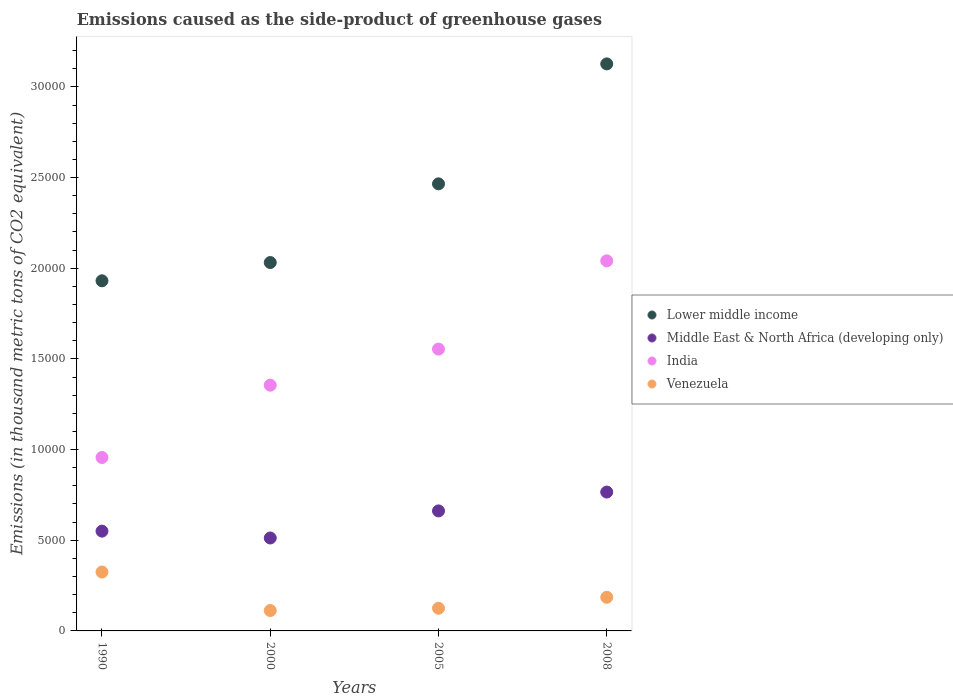How many different coloured dotlines are there?
Make the answer very short. 4. What is the emissions caused as the side-product of greenhouse gases in Middle East & North Africa (developing only) in 2000?
Provide a succinct answer. 5124.9. Across all years, what is the maximum emissions caused as the side-product of greenhouse gases in Middle East & North Africa (developing only)?
Ensure brevity in your answer.  7657.2. Across all years, what is the minimum emissions caused as the side-product of greenhouse gases in Lower middle income?
Provide a short and direct response. 1.93e+04. In which year was the emissions caused as the side-product of greenhouse gases in Lower middle income maximum?
Keep it short and to the point. 2008. What is the total emissions caused as the side-product of greenhouse gases in Middle East & North Africa (developing only) in the graph?
Your answer should be compact. 2.49e+04. What is the difference between the emissions caused as the side-product of greenhouse gases in India in 2000 and that in 2005?
Offer a terse response. -1989. What is the difference between the emissions caused as the side-product of greenhouse gases in Venezuela in 1990 and the emissions caused as the side-product of greenhouse gases in Lower middle income in 2008?
Keep it short and to the point. -2.80e+04. What is the average emissions caused as the side-product of greenhouse gases in Middle East & North Africa (developing only) per year?
Offer a terse response. 6225.62. In the year 2000, what is the difference between the emissions caused as the side-product of greenhouse gases in Venezuela and emissions caused as the side-product of greenhouse gases in India?
Offer a terse response. -1.24e+04. In how many years, is the emissions caused as the side-product of greenhouse gases in Venezuela greater than 30000 thousand metric tons?
Your answer should be very brief. 0. What is the ratio of the emissions caused as the side-product of greenhouse gases in Venezuela in 1990 to that in 2005?
Offer a terse response. 2.6. What is the difference between the highest and the second highest emissions caused as the side-product of greenhouse gases in Middle East & North Africa (developing only)?
Your answer should be very brief. 1039.4. What is the difference between the highest and the lowest emissions caused as the side-product of greenhouse gases in Middle East & North Africa (developing only)?
Your answer should be compact. 2532.3. In how many years, is the emissions caused as the side-product of greenhouse gases in Middle East & North Africa (developing only) greater than the average emissions caused as the side-product of greenhouse gases in Middle East & North Africa (developing only) taken over all years?
Offer a very short reply. 2. Is the sum of the emissions caused as the side-product of greenhouse gases in Middle East & North Africa (developing only) in 2005 and 2008 greater than the maximum emissions caused as the side-product of greenhouse gases in India across all years?
Provide a short and direct response. No. Is it the case that in every year, the sum of the emissions caused as the side-product of greenhouse gases in Lower middle income and emissions caused as the side-product of greenhouse gases in India  is greater than the emissions caused as the side-product of greenhouse gases in Venezuela?
Keep it short and to the point. Yes. Does the emissions caused as the side-product of greenhouse gases in Venezuela monotonically increase over the years?
Provide a succinct answer. No. Is the emissions caused as the side-product of greenhouse gases in Middle East & North Africa (developing only) strictly greater than the emissions caused as the side-product of greenhouse gases in Venezuela over the years?
Offer a very short reply. Yes. Is the emissions caused as the side-product of greenhouse gases in Lower middle income strictly less than the emissions caused as the side-product of greenhouse gases in India over the years?
Keep it short and to the point. No. How many years are there in the graph?
Provide a short and direct response. 4. Are the values on the major ticks of Y-axis written in scientific E-notation?
Provide a succinct answer. No. Where does the legend appear in the graph?
Your response must be concise. Center right. How many legend labels are there?
Keep it short and to the point. 4. What is the title of the graph?
Your response must be concise. Emissions caused as the side-product of greenhouse gases. What is the label or title of the Y-axis?
Your answer should be very brief. Emissions (in thousand metric tons of CO2 equivalent). What is the Emissions (in thousand metric tons of CO2 equivalent) in Lower middle income in 1990?
Your response must be concise. 1.93e+04. What is the Emissions (in thousand metric tons of CO2 equivalent) in Middle East & North Africa (developing only) in 1990?
Give a very brief answer. 5502.6. What is the Emissions (in thousand metric tons of CO2 equivalent) of India in 1990?
Your answer should be compact. 9563.6. What is the Emissions (in thousand metric tons of CO2 equivalent) of Venezuela in 1990?
Offer a terse response. 3248.1. What is the Emissions (in thousand metric tons of CO2 equivalent) of Lower middle income in 2000?
Ensure brevity in your answer.  2.03e+04. What is the Emissions (in thousand metric tons of CO2 equivalent) in Middle East & North Africa (developing only) in 2000?
Your response must be concise. 5124.9. What is the Emissions (in thousand metric tons of CO2 equivalent) of India in 2000?
Make the answer very short. 1.36e+04. What is the Emissions (in thousand metric tons of CO2 equivalent) in Venezuela in 2000?
Provide a succinct answer. 1124.5. What is the Emissions (in thousand metric tons of CO2 equivalent) in Lower middle income in 2005?
Make the answer very short. 2.47e+04. What is the Emissions (in thousand metric tons of CO2 equivalent) in Middle East & North Africa (developing only) in 2005?
Your answer should be very brief. 6617.8. What is the Emissions (in thousand metric tons of CO2 equivalent) of India in 2005?
Provide a succinct answer. 1.55e+04. What is the Emissions (in thousand metric tons of CO2 equivalent) in Venezuela in 2005?
Make the answer very short. 1249.6. What is the Emissions (in thousand metric tons of CO2 equivalent) of Lower middle income in 2008?
Ensure brevity in your answer.  3.13e+04. What is the Emissions (in thousand metric tons of CO2 equivalent) in Middle East & North Africa (developing only) in 2008?
Offer a very short reply. 7657.2. What is the Emissions (in thousand metric tons of CO2 equivalent) in India in 2008?
Your response must be concise. 2.04e+04. What is the Emissions (in thousand metric tons of CO2 equivalent) in Venezuela in 2008?
Offer a terse response. 1854.3. Across all years, what is the maximum Emissions (in thousand metric tons of CO2 equivalent) in Lower middle income?
Your response must be concise. 3.13e+04. Across all years, what is the maximum Emissions (in thousand metric tons of CO2 equivalent) of Middle East & North Africa (developing only)?
Provide a short and direct response. 7657.2. Across all years, what is the maximum Emissions (in thousand metric tons of CO2 equivalent) in India?
Make the answer very short. 2.04e+04. Across all years, what is the maximum Emissions (in thousand metric tons of CO2 equivalent) in Venezuela?
Keep it short and to the point. 3248.1. Across all years, what is the minimum Emissions (in thousand metric tons of CO2 equivalent) in Lower middle income?
Offer a very short reply. 1.93e+04. Across all years, what is the minimum Emissions (in thousand metric tons of CO2 equivalent) in Middle East & North Africa (developing only)?
Make the answer very short. 5124.9. Across all years, what is the minimum Emissions (in thousand metric tons of CO2 equivalent) in India?
Provide a short and direct response. 9563.6. Across all years, what is the minimum Emissions (in thousand metric tons of CO2 equivalent) in Venezuela?
Provide a succinct answer. 1124.5. What is the total Emissions (in thousand metric tons of CO2 equivalent) in Lower middle income in the graph?
Keep it short and to the point. 9.55e+04. What is the total Emissions (in thousand metric tons of CO2 equivalent) in Middle East & North Africa (developing only) in the graph?
Provide a succinct answer. 2.49e+04. What is the total Emissions (in thousand metric tons of CO2 equivalent) in India in the graph?
Provide a short and direct response. 5.91e+04. What is the total Emissions (in thousand metric tons of CO2 equivalent) in Venezuela in the graph?
Provide a short and direct response. 7476.5. What is the difference between the Emissions (in thousand metric tons of CO2 equivalent) in Lower middle income in 1990 and that in 2000?
Provide a short and direct response. -1007.9. What is the difference between the Emissions (in thousand metric tons of CO2 equivalent) of Middle East & North Africa (developing only) in 1990 and that in 2000?
Provide a succinct answer. 377.7. What is the difference between the Emissions (in thousand metric tons of CO2 equivalent) of India in 1990 and that in 2000?
Keep it short and to the point. -3987.1. What is the difference between the Emissions (in thousand metric tons of CO2 equivalent) in Venezuela in 1990 and that in 2000?
Your answer should be compact. 2123.6. What is the difference between the Emissions (in thousand metric tons of CO2 equivalent) in Lower middle income in 1990 and that in 2005?
Your response must be concise. -5347. What is the difference between the Emissions (in thousand metric tons of CO2 equivalent) of Middle East & North Africa (developing only) in 1990 and that in 2005?
Offer a very short reply. -1115.2. What is the difference between the Emissions (in thousand metric tons of CO2 equivalent) in India in 1990 and that in 2005?
Make the answer very short. -5976.1. What is the difference between the Emissions (in thousand metric tons of CO2 equivalent) of Venezuela in 1990 and that in 2005?
Your response must be concise. 1998.5. What is the difference between the Emissions (in thousand metric tons of CO2 equivalent) of Lower middle income in 1990 and that in 2008?
Provide a short and direct response. -1.20e+04. What is the difference between the Emissions (in thousand metric tons of CO2 equivalent) in Middle East & North Africa (developing only) in 1990 and that in 2008?
Your answer should be compact. -2154.6. What is the difference between the Emissions (in thousand metric tons of CO2 equivalent) of India in 1990 and that in 2008?
Ensure brevity in your answer.  -1.08e+04. What is the difference between the Emissions (in thousand metric tons of CO2 equivalent) in Venezuela in 1990 and that in 2008?
Your response must be concise. 1393.8. What is the difference between the Emissions (in thousand metric tons of CO2 equivalent) in Lower middle income in 2000 and that in 2005?
Provide a succinct answer. -4339.1. What is the difference between the Emissions (in thousand metric tons of CO2 equivalent) in Middle East & North Africa (developing only) in 2000 and that in 2005?
Provide a succinct answer. -1492.9. What is the difference between the Emissions (in thousand metric tons of CO2 equivalent) of India in 2000 and that in 2005?
Keep it short and to the point. -1989. What is the difference between the Emissions (in thousand metric tons of CO2 equivalent) in Venezuela in 2000 and that in 2005?
Keep it short and to the point. -125.1. What is the difference between the Emissions (in thousand metric tons of CO2 equivalent) of Lower middle income in 2000 and that in 2008?
Provide a short and direct response. -1.10e+04. What is the difference between the Emissions (in thousand metric tons of CO2 equivalent) in Middle East & North Africa (developing only) in 2000 and that in 2008?
Make the answer very short. -2532.3. What is the difference between the Emissions (in thousand metric tons of CO2 equivalent) of India in 2000 and that in 2008?
Keep it short and to the point. -6856.2. What is the difference between the Emissions (in thousand metric tons of CO2 equivalent) in Venezuela in 2000 and that in 2008?
Provide a short and direct response. -729.8. What is the difference between the Emissions (in thousand metric tons of CO2 equivalent) of Lower middle income in 2005 and that in 2008?
Your answer should be very brief. -6613.6. What is the difference between the Emissions (in thousand metric tons of CO2 equivalent) in Middle East & North Africa (developing only) in 2005 and that in 2008?
Provide a succinct answer. -1039.4. What is the difference between the Emissions (in thousand metric tons of CO2 equivalent) of India in 2005 and that in 2008?
Provide a succinct answer. -4867.2. What is the difference between the Emissions (in thousand metric tons of CO2 equivalent) of Venezuela in 2005 and that in 2008?
Your answer should be compact. -604.7. What is the difference between the Emissions (in thousand metric tons of CO2 equivalent) in Lower middle income in 1990 and the Emissions (in thousand metric tons of CO2 equivalent) in Middle East & North Africa (developing only) in 2000?
Your answer should be compact. 1.42e+04. What is the difference between the Emissions (in thousand metric tons of CO2 equivalent) in Lower middle income in 1990 and the Emissions (in thousand metric tons of CO2 equivalent) in India in 2000?
Your answer should be compact. 5755.7. What is the difference between the Emissions (in thousand metric tons of CO2 equivalent) in Lower middle income in 1990 and the Emissions (in thousand metric tons of CO2 equivalent) in Venezuela in 2000?
Keep it short and to the point. 1.82e+04. What is the difference between the Emissions (in thousand metric tons of CO2 equivalent) of Middle East & North Africa (developing only) in 1990 and the Emissions (in thousand metric tons of CO2 equivalent) of India in 2000?
Offer a terse response. -8048.1. What is the difference between the Emissions (in thousand metric tons of CO2 equivalent) of Middle East & North Africa (developing only) in 1990 and the Emissions (in thousand metric tons of CO2 equivalent) of Venezuela in 2000?
Provide a short and direct response. 4378.1. What is the difference between the Emissions (in thousand metric tons of CO2 equivalent) of India in 1990 and the Emissions (in thousand metric tons of CO2 equivalent) of Venezuela in 2000?
Your answer should be compact. 8439.1. What is the difference between the Emissions (in thousand metric tons of CO2 equivalent) of Lower middle income in 1990 and the Emissions (in thousand metric tons of CO2 equivalent) of Middle East & North Africa (developing only) in 2005?
Your answer should be compact. 1.27e+04. What is the difference between the Emissions (in thousand metric tons of CO2 equivalent) of Lower middle income in 1990 and the Emissions (in thousand metric tons of CO2 equivalent) of India in 2005?
Give a very brief answer. 3766.7. What is the difference between the Emissions (in thousand metric tons of CO2 equivalent) of Lower middle income in 1990 and the Emissions (in thousand metric tons of CO2 equivalent) of Venezuela in 2005?
Give a very brief answer. 1.81e+04. What is the difference between the Emissions (in thousand metric tons of CO2 equivalent) in Middle East & North Africa (developing only) in 1990 and the Emissions (in thousand metric tons of CO2 equivalent) in India in 2005?
Offer a very short reply. -1.00e+04. What is the difference between the Emissions (in thousand metric tons of CO2 equivalent) in Middle East & North Africa (developing only) in 1990 and the Emissions (in thousand metric tons of CO2 equivalent) in Venezuela in 2005?
Your answer should be very brief. 4253. What is the difference between the Emissions (in thousand metric tons of CO2 equivalent) in India in 1990 and the Emissions (in thousand metric tons of CO2 equivalent) in Venezuela in 2005?
Make the answer very short. 8314. What is the difference between the Emissions (in thousand metric tons of CO2 equivalent) of Lower middle income in 1990 and the Emissions (in thousand metric tons of CO2 equivalent) of Middle East & North Africa (developing only) in 2008?
Keep it short and to the point. 1.16e+04. What is the difference between the Emissions (in thousand metric tons of CO2 equivalent) of Lower middle income in 1990 and the Emissions (in thousand metric tons of CO2 equivalent) of India in 2008?
Offer a very short reply. -1100.5. What is the difference between the Emissions (in thousand metric tons of CO2 equivalent) of Lower middle income in 1990 and the Emissions (in thousand metric tons of CO2 equivalent) of Venezuela in 2008?
Provide a succinct answer. 1.75e+04. What is the difference between the Emissions (in thousand metric tons of CO2 equivalent) in Middle East & North Africa (developing only) in 1990 and the Emissions (in thousand metric tons of CO2 equivalent) in India in 2008?
Provide a succinct answer. -1.49e+04. What is the difference between the Emissions (in thousand metric tons of CO2 equivalent) in Middle East & North Africa (developing only) in 1990 and the Emissions (in thousand metric tons of CO2 equivalent) in Venezuela in 2008?
Make the answer very short. 3648.3. What is the difference between the Emissions (in thousand metric tons of CO2 equivalent) of India in 1990 and the Emissions (in thousand metric tons of CO2 equivalent) of Venezuela in 2008?
Give a very brief answer. 7709.3. What is the difference between the Emissions (in thousand metric tons of CO2 equivalent) of Lower middle income in 2000 and the Emissions (in thousand metric tons of CO2 equivalent) of Middle East & North Africa (developing only) in 2005?
Offer a terse response. 1.37e+04. What is the difference between the Emissions (in thousand metric tons of CO2 equivalent) of Lower middle income in 2000 and the Emissions (in thousand metric tons of CO2 equivalent) of India in 2005?
Your answer should be very brief. 4774.6. What is the difference between the Emissions (in thousand metric tons of CO2 equivalent) in Lower middle income in 2000 and the Emissions (in thousand metric tons of CO2 equivalent) in Venezuela in 2005?
Give a very brief answer. 1.91e+04. What is the difference between the Emissions (in thousand metric tons of CO2 equivalent) in Middle East & North Africa (developing only) in 2000 and the Emissions (in thousand metric tons of CO2 equivalent) in India in 2005?
Your answer should be compact. -1.04e+04. What is the difference between the Emissions (in thousand metric tons of CO2 equivalent) in Middle East & North Africa (developing only) in 2000 and the Emissions (in thousand metric tons of CO2 equivalent) in Venezuela in 2005?
Your answer should be compact. 3875.3. What is the difference between the Emissions (in thousand metric tons of CO2 equivalent) of India in 2000 and the Emissions (in thousand metric tons of CO2 equivalent) of Venezuela in 2005?
Provide a short and direct response. 1.23e+04. What is the difference between the Emissions (in thousand metric tons of CO2 equivalent) in Lower middle income in 2000 and the Emissions (in thousand metric tons of CO2 equivalent) in Middle East & North Africa (developing only) in 2008?
Keep it short and to the point. 1.27e+04. What is the difference between the Emissions (in thousand metric tons of CO2 equivalent) in Lower middle income in 2000 and the Emissions (in thousand metric tons of CO2 equivalent) in India in 2008?
Make the answer very short. -92.6. What is the difference between the Emissions (in thousand metric tons of CO2 equivalent) of Lower middle income in 2000 and the Emissions (in thousand metric tons of CO2 equivalent) of Venezuela in 2008?
Ensure brevity in your answer.  1.85e+04. What is the difference between the Emissions (in thousand metric tons of CO2 equivalent) in Middle East & North Africa (developing only) in 2000 and the Emissions (in thousand metric tons of CO2 equivalent) in India in 2008?
Make the answer very short. -1.53e+04. What is the difference between the Emissions (in thousand metric tons of CO2 equivalent) of Middle East & North Africa (developing only) in 2000 and the Emissions (in thousand metric tons of CO2 equivalent) of Venezuela in 2008?
Offer a very short reply. 3270.6. What is the difference between the Emissions (in thousand metric tons of CO2 equivalent) of India in 2000 and the Emissions (in thousand metric tons of CO2 equivalent) of Venezuela in 2008?
Your answer should be very brief. 1.17e+04. What is the difference between the Emissions (in thousand metric tons of CO2 equivalent) of Lower middle income in 2005 and the Emissions (in thousand metric tons of CO2 equivalent) of Middle East & North Africa (developing only) in 2008?
Make the answer very short. 1.70e+04. What is the difference between the Emissions (in thousand metric tons of CO2 equivalent) in Lower middle income in 2005 and the Emissions (in thousand metric tons of CO2 equivalent) in India in 2008?
Ensure brevity in your answer.  4246.5. What is the difference between the Emissions (in thousand metric tons of CO2 equivalent) of Lower middle income in 2005 and the Emissions (in thousand metric tons of CO2 equivalent) of Venezuela in 2008?
Ensure brevity in your answer.  2.28e+04. What is the difference between the Emissions (in thousand metric tons of CO2 equivalent) of Middle East & North Africa (developing only) in 2005 and the Emissions (in thousand metric tons of CO2 equivalent) of India in 2008?
Provide a succinct answer. -1.38e+04. What is the difference between the Emissions (in thousand metric tons of CO2 equivalent) of Middle East & North Africa (developing only) in 2005 and the Emissions (in thousand metric tons of CO2 equivalent) of Venezuela in 2008?
Provide a succinct answer. 4763.5. What is the difference between the Emissions (in thousand metric tons of CO2 equivalent) of India in 2005 and the Emissions (in thousand metric tons of CO2 equivalent) of Venezuela in 2008?
Keep it short and to the point. 1.37e+04. What is the average Emissions (in thousand metric tons of CO2 equivalent) in Lower middle income per year?
Your response must be concise. 2.39e+04. What is the average Emissions (in thousand metric tons of CO2 equivalent) of Middle East & North Africa (developing only) per year?
Your answer should be very brief. 6225.62. What is the average Emissions (in thousand metric tons of CO2 equivalent) in India per year?
Make the answer very short. 1.48e+04. What is the average Emissions (in thousand metric tons of CO2 equivalent) in Venezuela per year?
Offer a terse response. 1869.12. In the year 1990, what is the difference between the Emissions (in thousand metric tons of CO2 equivalent) of Lower middle income and Emissions (in thousand metric tons of CO2 equivalent) of Middle East & North Africa (developing only)?
Provide a short and direct response. 1.38e+04. In the year 1990, what is the difference between the Emissions (in thousand metric tons of CO2 equivalent) of Lower middle income and Emissions (in thousand metric tons of CO2 equivalent) of India?
Ensure brevity in your answer.  9742.8. In the year 1990, what is the difference between the Emissions (in thousand metric tons of CO2 equivalent) in Lower middle income and Emissions (in thousand metric tons of CO2 equivalent) in Venezuela?
Offer a very short reply. 1.61e+04. In the year 1990, what is the difference between the Emissions (in thousand metric tons of CO2 equivalent) in Middle East & North Africa (developing only) and Emissions (in thousand metric tons of CO2 equivalent) in India?
Make the answer very short. -4061. In the year 1990, what is the difference between the Emissions (in thousand metric tons of CO2 equivalent) in Middle East & North Africa (developing only) and Emissions (in thousand metric tons of CO2 equivalent) in Venezuela?
Your answer should be very brief. 2254.5. In the year 1990, what is the difference between the Emissions (in thousand metric tons of CO2 equivalent) in India and Emissions (in thousand metric tons of CO2 equivalent) in Venezuela?
Keep it short and to the point. 6315.5. In the year 2000, what is the difference between the Emissions (in thousand metric tons of CO2 equivalent) in Lower middle income and Emissions (in thousand metric tons of CO2 equivalent) in Middle East & North Africa (developing only)?
Your answer should be compact. 1.52e+04. In the year 2000, what is the difference between the Emissions (in thousand metric tons of CO2 equivalent) of Lower middle income and Emissions (in thousand metric tons of CO2 equivalent) of India?
Your answer should be very brief. 6763.6. In the year 2000, what is the difference between the Emissions (in thousand metric tons of CO2 equivalent) of Lower middle income and Emissions (in thousand metric tons of CO2 equivalent) of Venezuela?
Make the answer very short. 1.92e+04. In the year 2000, what is the difference between the Emissions (in thousand metric tons of CO2 equivalent) in Middle East & North Africa (developing only) and Emissions (in thousand metric tons of CO2 equivalent) in India?
Provide a short and direct response. -8425.8. In the year 2000, what is the difference between the Emissions (in thousand metric tons of CO2 equivalent) in Middle East & North Africa (developing only) and Emissions (in thousand metric tons of CO2 equivalent) in Venezuela?
Your answer should be compact. 4000.4. In the year 2000, what is the difference between the Emissions (in thousand metric tons of CO2 equivalent) of India and Emissions (in thousand metric tons of CO2 equivalent) of Venezuela?
Your answer should be very brief. 1.24e+04. In the year 2005, what is the difference between the Emissions (in thousand metric tons of CO2 equivalent) of Lower middle income and Emissions (in thousand metric tons of CO2 equivalent) of Middle East & North Africa (developing only)?
Your answer should be compact. 1.80e+04. In the year 2005, what is the difference between the Emissions (in thousand metric tons of CO2 equivalent) of Lower middle income and Emissions (in thousand metric tons of CO2 equivalent) of India?
Give a very brief answer. 9113.7. In the year 2005, what is the difference between the Emissions (in thousand metric tons of CO2 equivalent) of Lower middle income and Emissions (in thousand metric tons of CO2 equivalent) of Venezuela?
Provide a succinct answer. 2.34e+04. In the year 2005, what is the difference between the Emissions (in thousand metric tons of CO2 equivalent) of Middle East & North Africa (developing only) and Emissions (in thousand metric tons of CO2 equivalent) of India?
Provide a short and direct response. -8921.9. In the year 2005, what is the difference between the Emissions (in thousand metric tons of CO2 equivalent) of Middle East & North Africa (developing only) and Emissions (in thousand metric tons of CO2 equivalent) of Venezuela?
Provide a succinct answer. 5368.2. In the year 2005, what is the difference between the Emissions (in thousand metric tons of CO2 equivalent) in India and Emissions (in thousand metric tons of CO2 equivalent) in Venezuela?
Offer a terse response. 1.43e+04. In the year 2008, what is the difference between the Emissions (in thousand metric tons of CO2 equivalent) of Lower middle income and Emissions (in thousand metric tons of CO2 equivalent) of Middle East & North Africa (developing only)?
Offer a very short reply. 2.36e+04. In the year 2008, what is the difference between the Emissions (in thousand metric tons of CO2 equivalent) in Lower middle income and Emissions (in thousand metric tons of CO2 equivalent) in India?
Offer a very short reply. 1.09e+04. In the year 2008, what is the difference between the Emissions (in thousand metric tons of CO2 equivalent) in Lower middle income and Emissions (in thousand metric tons of CO2 equivalent) in Venezuela?
Your answer should be compact. 2.94e+04. In the year 2008, what is the difference between the Emissions (in thousand metric tons of CO2 equivalent) of Middle East & North Africa (developing only) and Emissions (in thousand metric tons of CO2 equivalent) of India?
Offer a terse response. -1.27e+04. In the year 2008, what is the difference between the Emissions (in thousand metric tons of CO2 equivalent) in Middle East & North Africa (developing only) and Emissions (in thousand metric tons of CO2 equivalent) in Venezuela?
Make the answer very short. 5802.9. In the year 2008, what is the difference between the Emissions (in thousand metric tons of CO2 equivalent) of India and Emissions (in thousand metric tons of CO2 equivalent) of Venezuela?
Your answer should be very brief. 1.86e+04. What is the ratio of the Emissions (in thousand metric tons of CO2 equivalent) in Lower middle income in 1990 to that in 2000?
Ensure brevity in your answer.  0.95. What is the ratio of the Emissions (in thousand metric tons of CO2 equivalent) of Middle East & North Africa (developing only) in 1990 to that in 2000?
Keep it short and to the point. 1.07. What is the ratio of the Emissions (in thousand metric tons of CO2 equivalent) in India in 1990 to that in 2000?
Provide a short and direct response. 0.71. What is the ratio of the Emissions (in thousand metric tons of CO2 equivalent) of Venezuela in 1990 to that in 2000?
Ensure brevity in your answer.  2.89. What is the ratio of the Emissions (in thousand metric tons of CO2 equivalent) in Lower middle income in 1990 to that in 2005?
Your answer should be compact. 0.78. What is the ratio of the Emissions (in thousand metric tons of CO2 equivalent) of Middle East & North Africa (developing only) in 1990 to that in 2005?
Ensure brevity in your answer.  0.83. What is the ratio of the Emissions (in thousand metric tons of CO2 equivalent) of India in 1990 to that in 2005?
Give a very brief answer. 0.62. What is the ratio of the Emissions (in thousand metric tons of CO2 equivalent) of Venezuela in 1990 to that in 2005?
Your response must be concise. 2.6. What is the ratio of the Emissions (in thousand metric tons of CO2 equivalent) of Lower middle income in 1990 to that in 2008?
Offer a very short reply. 0.62. What is the ratio of the Emissions (in thousand metric tons of CO2 equivalent) of Middle East & North Africa (developing only) in 1990 to that in 2008?
Your answer should be very brief. 0.72. What is the ratio of the Emissions (in thousand metric tons of CO2 equivalent) in India in 1990 to that in 2008?
Make the answer very short. 0.47. What is the ratio of the Emissions (in thousand metric tons of CO2 equivalent) in Venezuela in 1990 to that in 2008?
Provide a short and direct response. 1.75. What is the ratio of the Emissions (in thousand metric tons of CO2 equivalent) of Lower middle income in 2000 to that in 2005?
Your answer should be very brief. 0.82. What is the ratio of the Emissions (in thousand metric tons of CO2 equivalent) in Middle East & North Africa (developing only) in 2000 to that in 2005?
Your response must be concise. 0.77. What is the ratio of the Emissions (in thousand metric tons of CO2 equivalent) of India in 2000 to that in 2005?
Give a very brief answer. 0.87. What is the ratio of the Emissions (in thousand metric tons of CO2 equivalent) in Venezuela in 2000 to that in 2005?
Make the answer very short. 0.9. What is the ratio of the Emissions (in thousand metric tons of CO2 equivalent) in Lower middle income in 2000 to that in 2008?
Offer a terse response. 0.65. What is the ratio of the Emissions (in thousand metric tons of CO2 equivalent) in Middle East & North Africa (developing only) in 2000 to that in 2008?
Provide a short and direct response. 0.67. What is the ratio of the Emissions (in thousand metric tons of CO2 equivalent) of India in 2000 to that in 2008?
Your answer should be very brief. 0.66. What is the ratio of the Emissions (in thousand metric tons of CO2 equivalent) of Venezuela in 2000 to that in 2008?
Provide a short and direct response. 0.61. What is the ratio of the Emissions (in thousand metric tons of CO2 equivalent) in Lower middle income in 2005 to that in 2008?
Give a very brief answer. 0.79. What is the ratio of the Emissions (in thousand metric tons of CO2 equivalent) in Middle East & North Africa (developing only) in 2005 to that in 2008?
Provide a short and direct response. 0.86. What is the ratio of the Emissions (in thousand metric tons of CO2 equivalent) of India in 2005 to that in 2008?
Provide a succinct answer. 0.76. What is the ratio of the Emissions (in thousand metric tons of CO2 equivalent) in Venezuela in 2005 to that in 2008?
Provide a short and direct response. 0.67. What is the difference between the highest and the second highest Emissions (in thousand metric tons of CO2 equivalent) in Lower middle income?
Your answer should be very brief. 6613.6. What is the difference between the highest and the second highest Emissions (in thousand metric tons of CO2 equivalent) of Middle East & North Africa (developing only)?
Keep it short and to the point. 1039.4. What is the difference between the highest and the second highest Emissions (in thousand metric tons of CO2 equivalent) in India?
Keep it short and to the point. 4867.2. What is the difference between the highest and the second highest Emissions (in thousand metric tons of CO2 equivalent) in Venezuela?
Keep it short and to the point. 1393.8. What is the difference between the highest and the lowest Emissions (in thousand metric tons of CO2 equivalent) of Lower middle income?
Keep it short and to the point. 1.20e+04. What is the difference between the highest and the lowest Emissions (in thousand metric tons of CO2 equivalent) in Middle East & North Africa (developing only)?
Your response must be concise. 2532.3. What is the difference between the highest and the lowest Emissions (in thousand metric tons of CO2 equivalent) of India?
Your answer should be very brief. 1.08e+04. What is the difference between the highest and the lowest Emissions (in thousand metric tons of CO2 equivalent) of Venezuela?
Provide a succinct answer. 2123.6. 